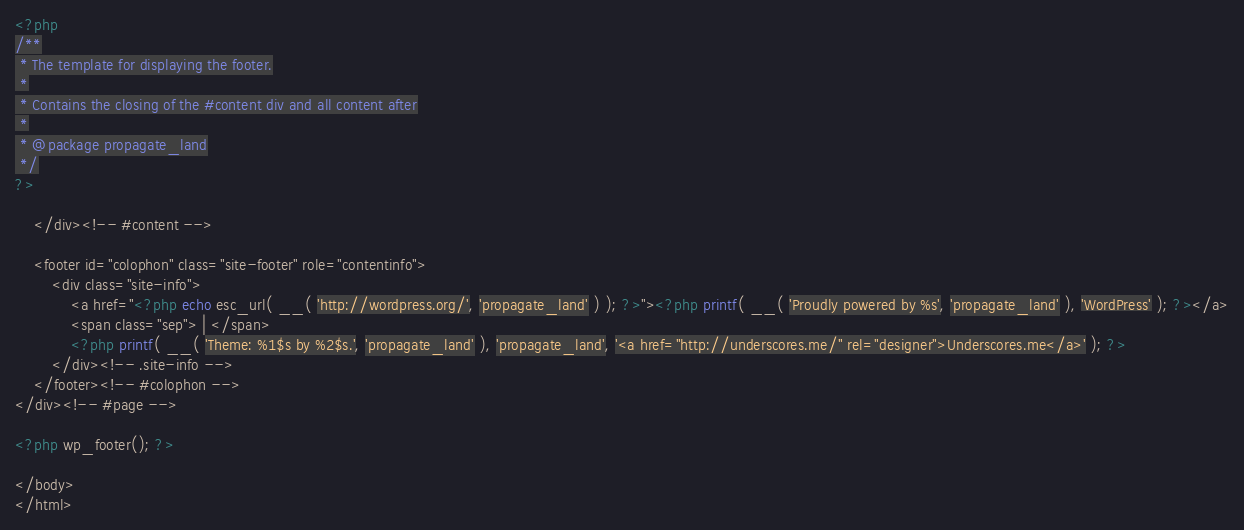<code> <loc_0><loc_0><loc_500><loc_500><_PHP_><?php
/**
 * The template for displaying the footer.
 *
 * Contains the closing of the #content div and all content after
 *
 * @package propagate_land
 */
?>

	</div><!-- #content -->

	<footer id="colophon" class="site-footer" role="contentinfo">
		<div class="site-info">
			<a href="<?php echo esc_url( __( 'http://wordpress.org/', 'propagate_land' ) ); ?>"><?php printf( __( 'Proudly powered by %s', 'propagate_land' ), 'WordPress' ); ?></a>
			<span class="sep"> | </span>
			<?php printf( __( 'Theme: %1$s by %2$s.', 'propagate_land' ), 'propagate_land', '<a href="http://underscores.me/" rel="designer">Underscores.me</a>' ); ?>
		</div><!-- .site-info -->
	</footer><!-- #colophon -->
</div><!-- #page -->

<?php wp_footer(); ?>

</body>
</html>
</code> 